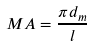<formula> <loc_0><loc_0><loc_500><loc_500>M A = \frac { \pi d _ { m } } { l }</formula> 